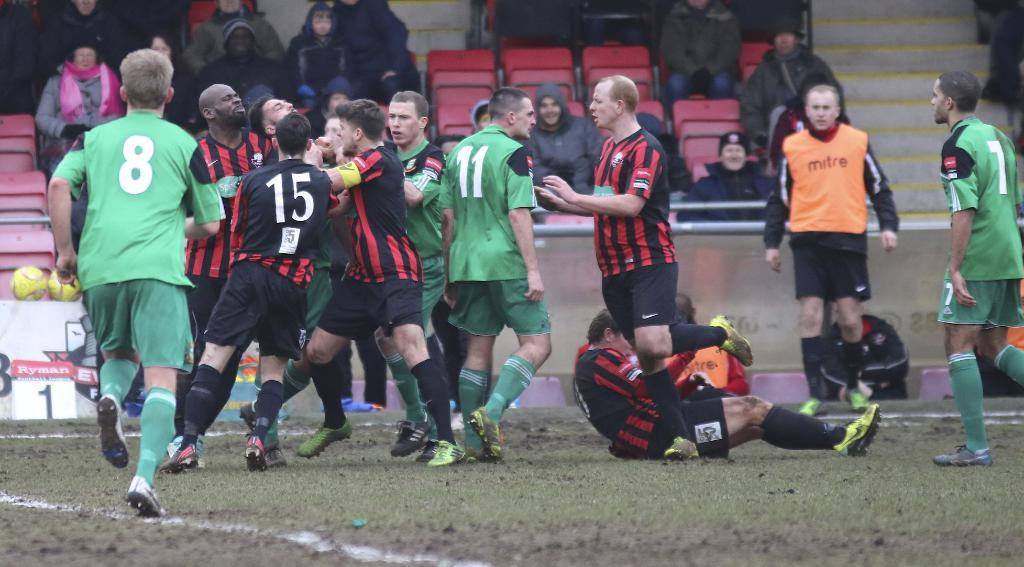What are the players in the image doing? The players are standing on the ground. What can be seen in the background of the image? There is a fencing, a crowd, chairs, stairs, and a wall in the background. Where is the tub located in the image? There is no tub present in the image. What type of party is happening in the image? There is no party happening in the image; it features players standing on the ground and a background with various elements. 